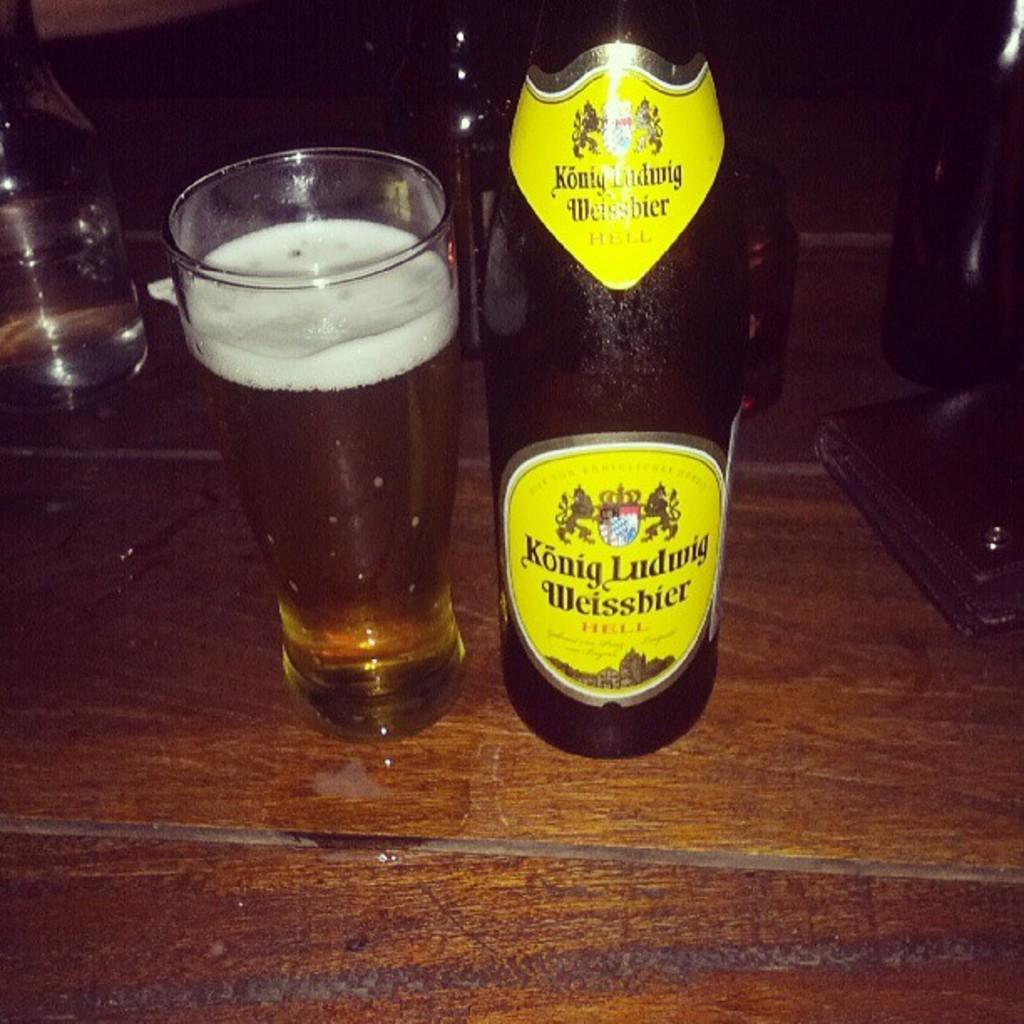<image>
Share a concise interpretation of the image provided. Bottle of Konig Ludwig Weisshier next to a cup of beer. 